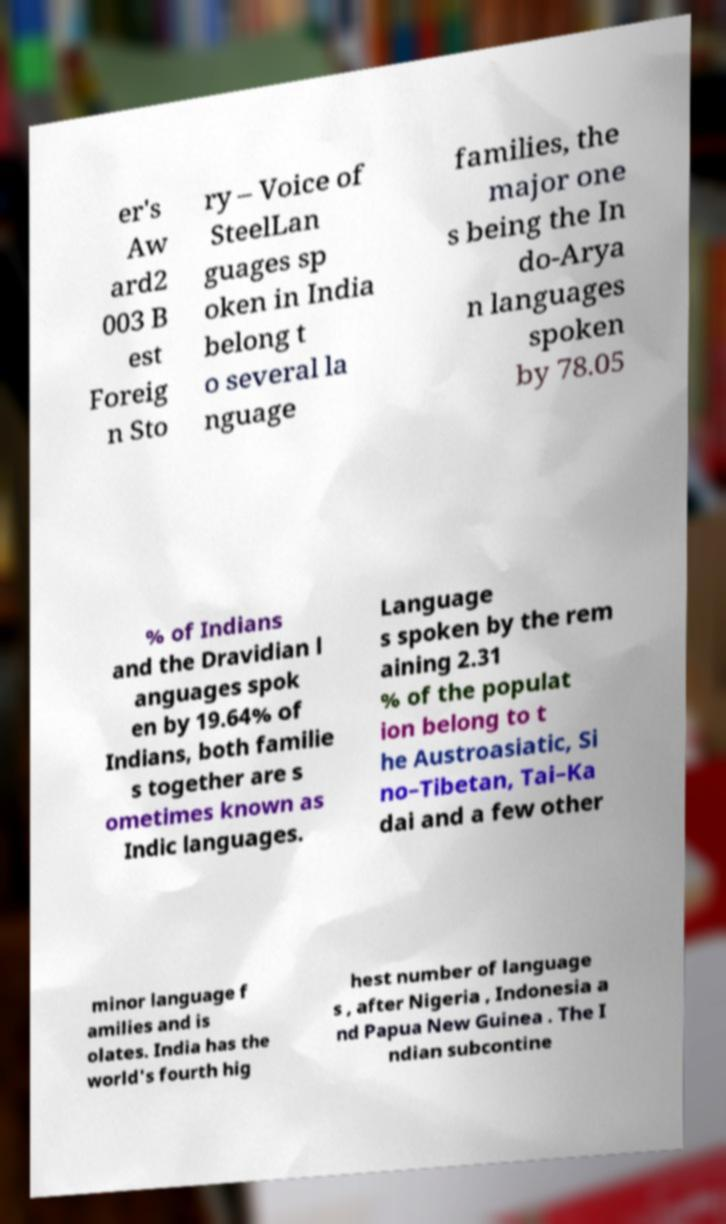Could you assist in decoding the text presented in this image and type it out clearly? er's Aw ard2 003 B est Foreig n Sto ry – Voice of SteelLan guages sp oken in India belong t o several la nguage families, the major one s being the In do-Arya n languages spoken by 78.05 % of Indians and the Dravidian l anguages spok en by 19.64% of Indians, both familie s together are s ometimes known as Indic languages. Language s spoken by the rem aining 2.31 % of the populat ion belong to t he Austroasiatic, Si no–Tibetan, Tai–Ka dai and a few other minor language f amilies and is olates. India has the world's fourth hig hest number of language s , after Nigeria , Indonesia a nd Papua New Guinea . The I ndian subcontine 